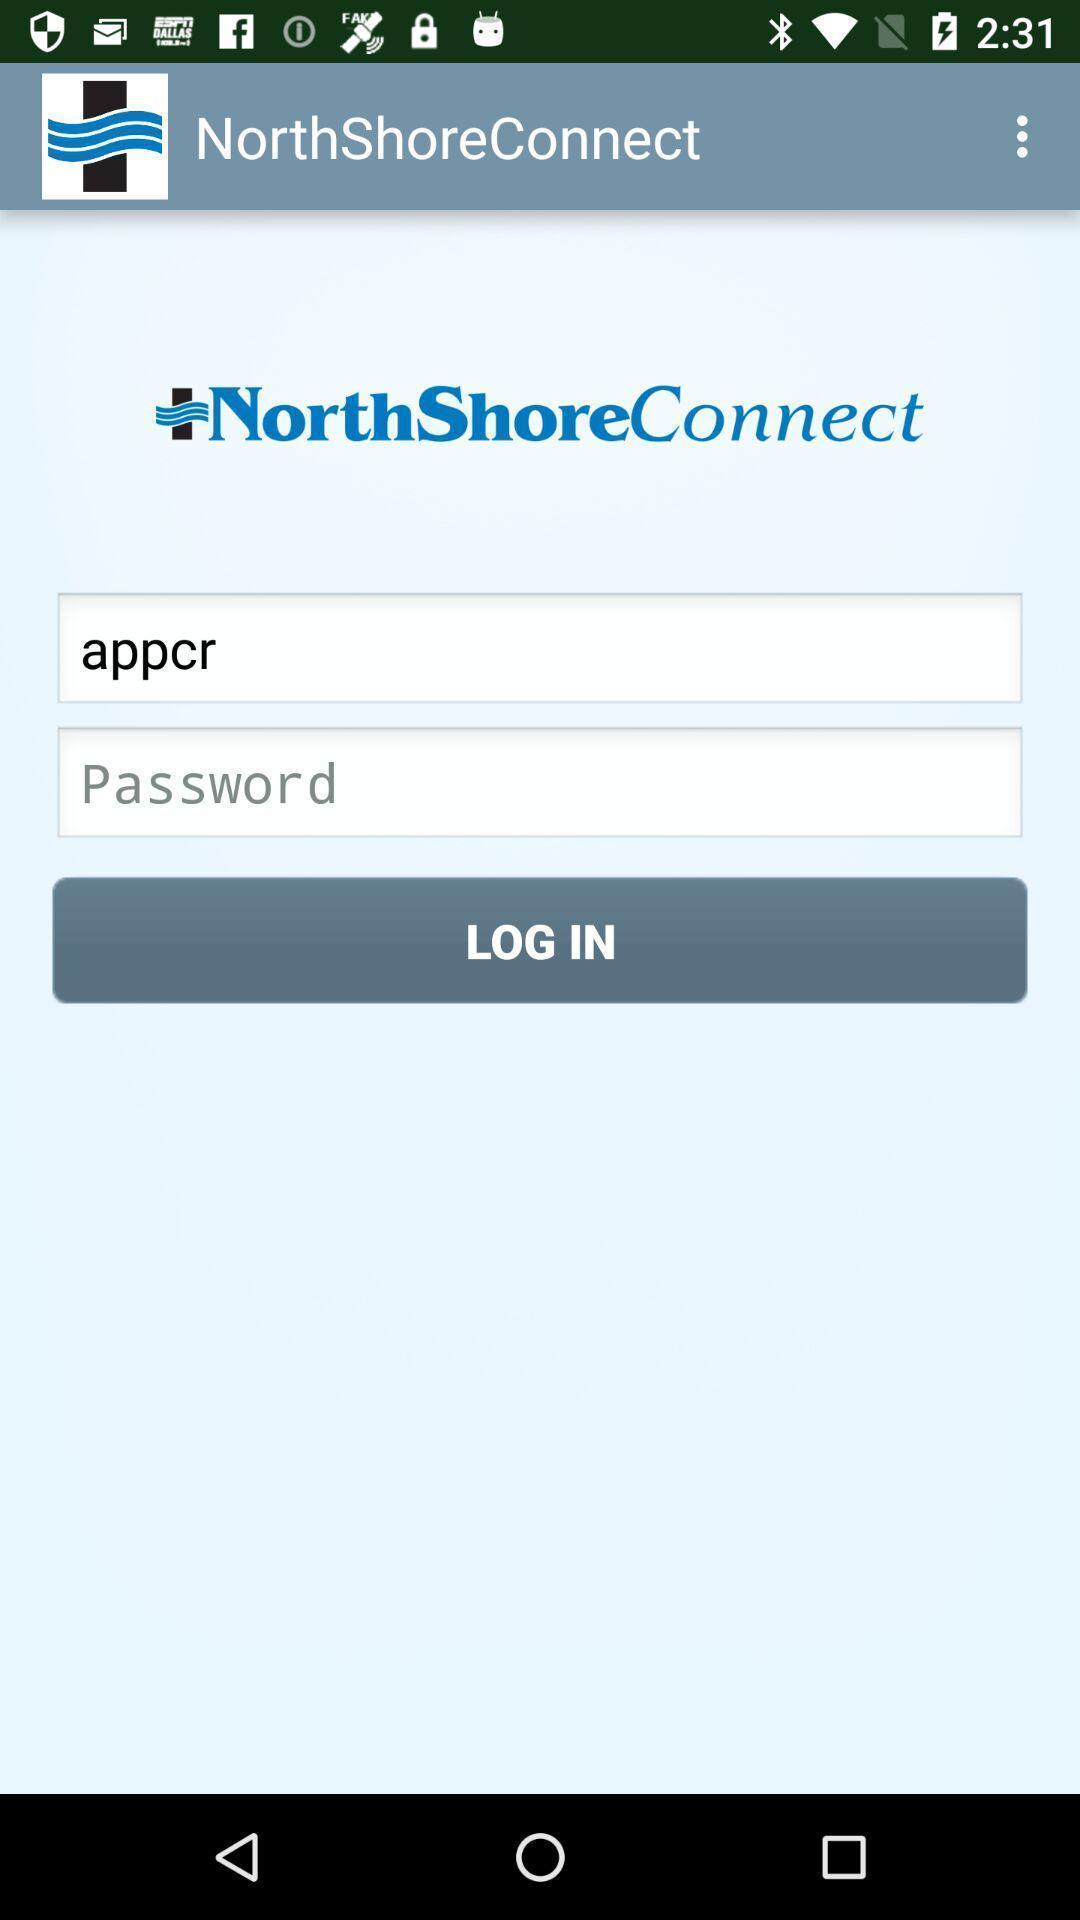Provide a detailed account of this screenshot. Welcome page of health care app. 